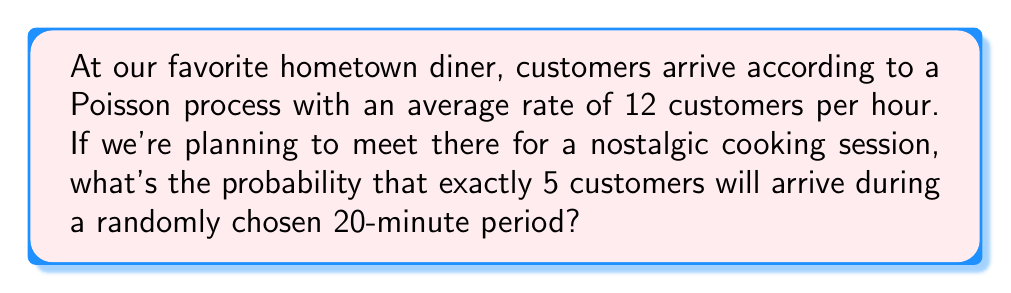Could you help me with this problem? Let's approach this step-by-step:

1) First, we need to calculate the average number of arrivals in a 20-minute period.
   The given rate is 12 customers per hour, so for 20 minutes:
   $\lambda = 12 \cdot \frac{20}{60} = 4$ customers

2) We're asked to find the probability of exactly 5 arrivals. In a Poisson process, this probability is given by the Poisson probability mass function:

   $$P(X = k) = \frac{e^{-\lambda}\lambda^k}{k!}$$

   where $\lambda$ is the average number of arrivals and $k$ is the number of arrivals we're interested in.

3) Plugging in our values ($\lambda = 4$, $k = 5$):

   $$P(X = 5) = \frac{e^{-4}4^5}{5!}$$

4) Let's calculate this step-by-step:
   
   $4^5 = 1024$
   $5! = 5 \cdot 4 \cdot 3 \cdot 2 \cdot 1 = 120$
   $e^{-4} \approx 0.0183$

   $$P(X = 5) = \frac{0.0183 \cdot 1024}{120} \approx 0.1563$$

5) Therefore, the probability is approximately 0.1563 or 15.63%.
Answer: 0.1563 